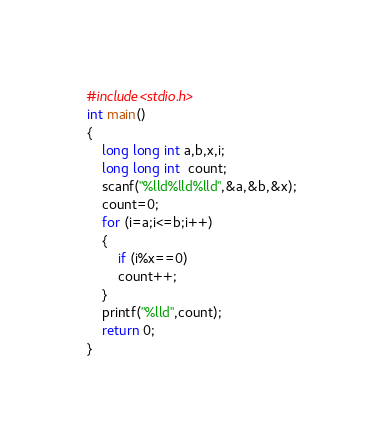<code> <loc_0><loc_0><loc_500><loc_500><_C_>#include<stdio.h>
int main()
{
	long long int a,b,x,i;
	long long int  count;	
	scanf("%lld%lld%lld",&a,&b,&x);
	count=0;
	for (i=a;i<=b;i++)
	{
		if (i%x==0)
		count++;
	}
	printf("%lld",count);
	return 0;
}</code> 